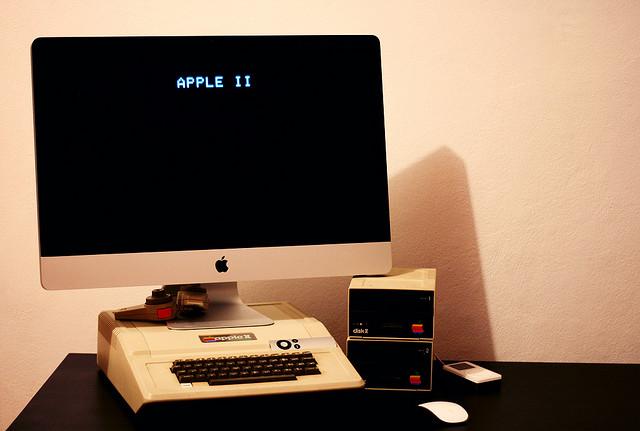Are these computers still manufactured?
Quick response, please. No. What company makes this computer?
Keep it brief. Apple. What does the screen say?
Quick response, please. Apple ii. 